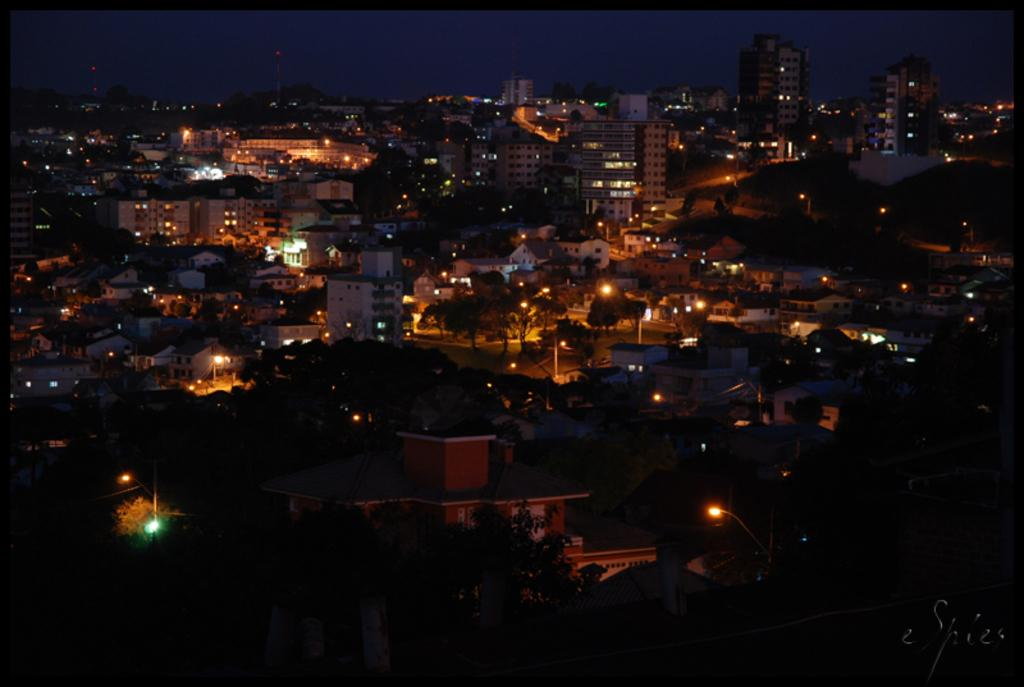What type of structures can be seen in the image? There are buildings in the image. What other natural elements are present in the image? There are trees in the image. Can you describe the lighting in the image? There is light in the foreground area of the image. When was the image captured? The image was captured during night time. What is the name of the person who captured the image? The name of the person who captured the image is not mentioned in the facts provided. Can you see a truck in the image? There is no truck present in the image. 